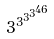Convert formula to latex. <formula><loc_0><loc_0><loc_500><loc_500>3 ^ { 3 ^ { 3 ^ { 3 ^ { 4 6 } } } }</formula> 